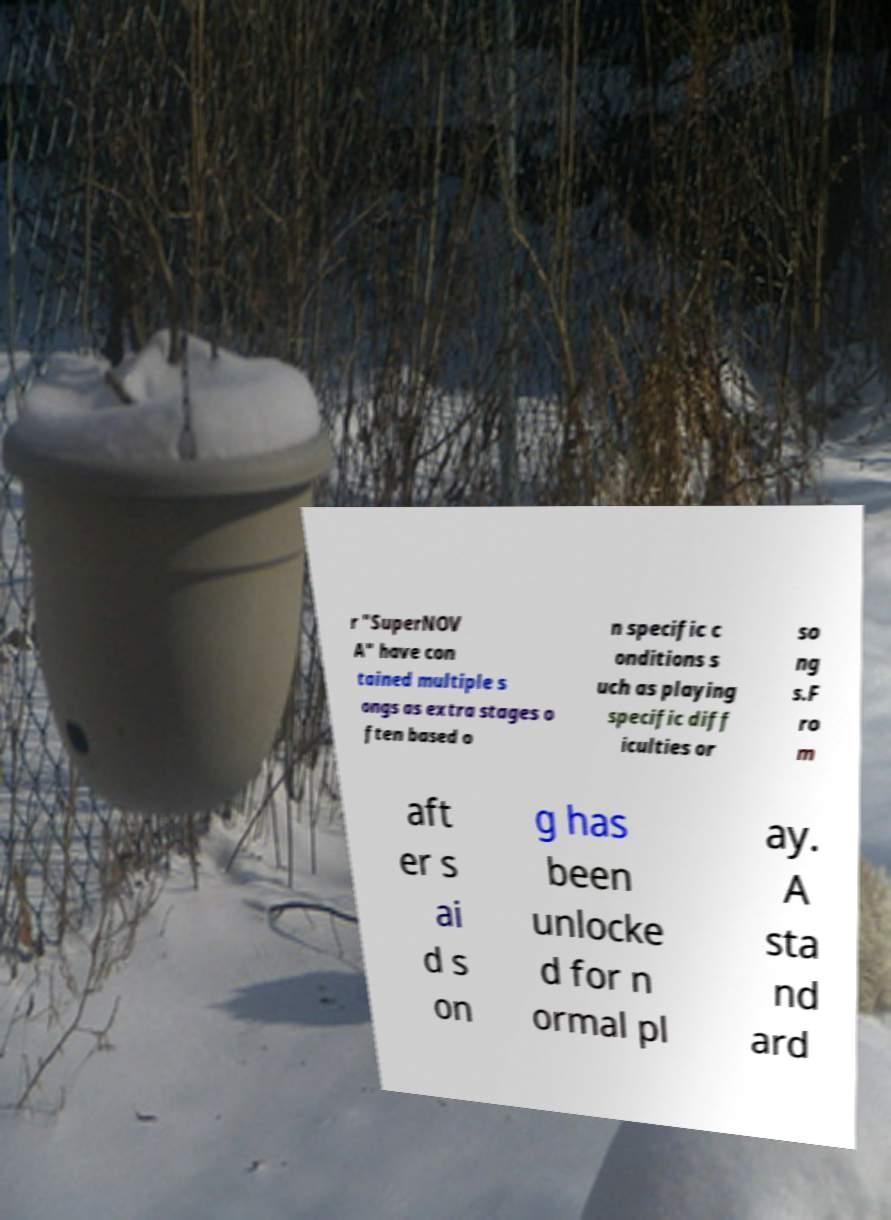Could you extract and type out the text from this image? r "SuperNOV A" have con tained multiple s ongs as extra stages o ften based o n specific c onditions s uch as playing specific diff iculties or so ng s.F ro m aft er s ai d s on g has been unlocke d for n ormal pl ay. A sta nd ard 